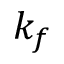Convert formula to latex. <formula><loc_0><loc_0><loc_500><loc_500>k _ { f }</formula> 